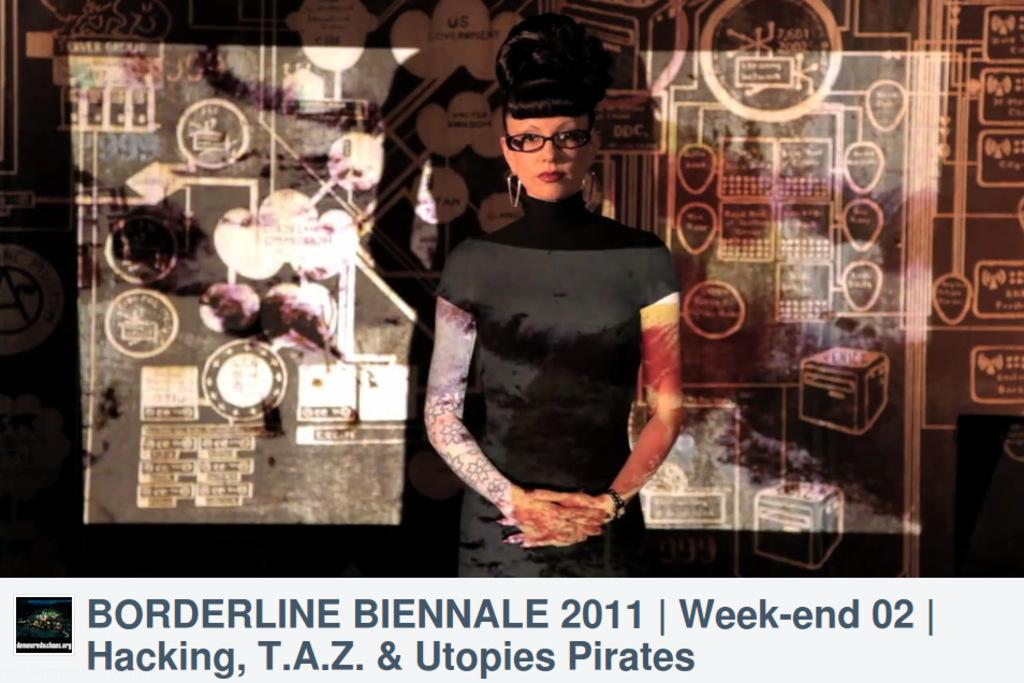What is the main subject of the image? There is a woman standing in the image. What is located behind the woman? There is a screen behind the woman. Are there any words or letters visible in the image? Yes, there is text on the wall in the image. Can you tell me how many cups are on the table in the image? There is no table or cup present in the image; it features a woman standing in front of a screen with text on the wall. 